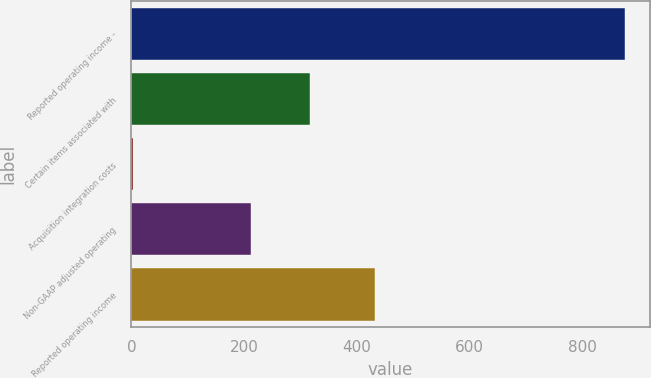Convert chart to OTSL. <chart><loc_0><loc_0><loc_500><loc_500><bar_chart><fcel>Reported operating income -<fcel>Certain items associated with<fcel>Acquisition integration costs<fcel>Non-GAAP adjusted operating<fcel>Reported operating income<nl><fcel>876<fcel>316.4<fcel>2<fcel>211.6<fcel>433<nl></chart> 